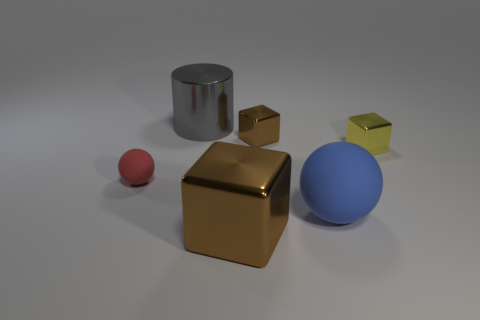Is the number of tiny yellow objects that are to the right of the yellow metal block the same as the number of tiny green shiny spheres?
Give a very brief answer. Yes. How many objects are cylinders or balls on the right side of the big gray object?
Make the answer very short. 2. Are there any tiny things that have the same material as the big gray cylinder?
Offer a terse response. Yes. What is the color of the big object that is the same shape as the tiny red thing?
Provide a short and direct response. Blue. Does the large brown block have the same material as the brown block behind the tiny sphere?
Your answer should be very brief. Yes. What is the shape of the brown metal object that is behind the metallic block in front of the yellow block?
Your answer should be very brief. Cube. There is a matte object that is on the left side of the gray metallic thing; does it have the same size as the blue ball?
Ensure brevity in your answer.  No. How many other things are there of the same shape as the large blue object?
Provide a succinct answer. 1. There is a shiny block that is behind the small yellow metallic thing; does it have the same color as the big cube?
Your answer should be compact. Yes. Is there a sphere of the same color as the cylinder?
Your response must be concise. No. 